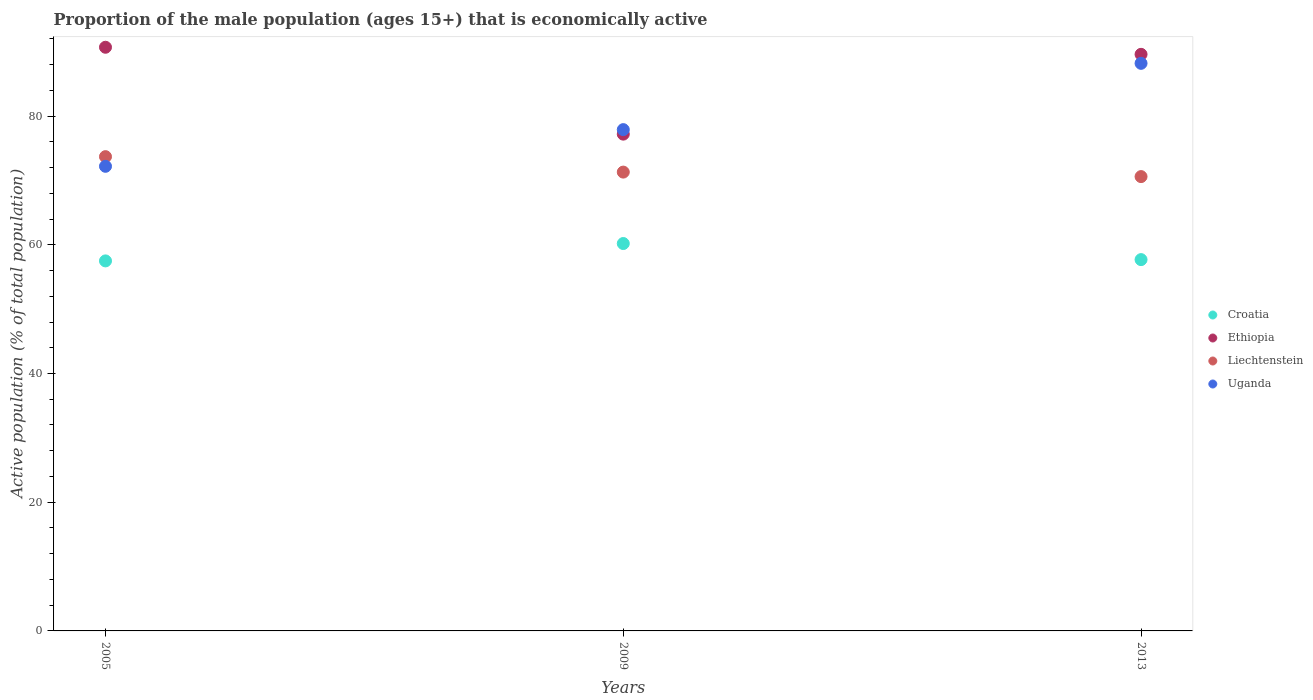How many different coloured dotlines are there?
Keep it short and to the point. 4. What is the proportion of the male population that is economically active in Croatia in 2005?
Provide a short and direct response. 57.5. Across all years, what is the maximum proportion of the male population that is economically active in Uganda?
Your response must be concise. 88.2. Across all years, what is the minimum proportion of the male population that is economically active in Uganda?
Offer a very short reply. 72.2. What is the total proportion of the male population that is economically active in Liechtenstein in the graph?
Keep it short and to the point. 215.6. What is the difference between the proportion of the male population that is economically active in Uganda in 2005 and that in 2009?
Ensure brevity in your answer.  -5.7. What is the difference between the proportion of the male population that is economically active in Liechtenstein in 2013 and the proportion of the male population that is economically active in Uganda in 2005?
Keep it short and to the point. -1.6. What is the average proportion of the male population that is economically active in Liechtenstein per year?
Your answer should be very brief. 71.87. In the year 2009, what is the difference between the proportion of the male population that is economically active in Liechtenstein and proportion of the male population that is economically active in Uganda?
Give a very brief answer. -6.6. What is the ratio of the proportion of the male population that is economically active in Croatia in 2009 to that in 2013?
Make the answer very short. 1.04. Is the proportion of the male population that is economically active in Croatia in 2005 less than that in 2009?
Make the answer very short. Yes. Is the difference between the proportion of the male population that is economically active in Liechtenstein in 2009 and 2013 greater than the difference between the proportion of the male population that is economically active in Uganda in 2009 and 2013?
Provide a short and direct response. Yes. What is the difference between the highest and the second highest proportion of the male population that is economically active in Ethiopia?
Your answer should be compact. 1.1. What is the difference between the highest and the lowest proportion of the male population that is economically active in Ethiopia?
Provide a short and direct response. 13.5. Is the sum of the proportion of the male population that is economically active in Liechtenstein in 2005 and 2013 greater than the maximum proportion of the male population that is economically active in Ethiopia across all years?
Your response must be concise. Yes. Is it the case that in every year, the sum of the proportion of the male population that is economically active in Croatia and proportion of the male population that is economically active in Uganda  is greater than the sum of proportion of the male population that is economically active in Liechtenstein and proportion of the male population that is economically active in Ethiopia?
Give a very brief answer. No. Does the proportion of the male population that is economically active in Ethiopia monotonically increase over the years?
Give a very brief answer. No. Is the proportion of the male population that is economically active in Croatia strictly greater than the proportion of the male population that is economically active in Ethiopia over the years?
Give a very brief answer. No. What is the difference between two consecutive major ticks on the Y-axis?
Offer a very short reply. 20. Are the values on the major ticks of Y-axis written in scientific E-notation?
Your response must be concise. No. Does the graph contain any zero values?
Your response must be concise. No. Does the graph contain grids?
Provide a short and direct response. No. How many legend labels are there?
Offer a very short reply. 4. How are the legend labels stacked?
Your answer should be very brief. Vertical. What is the title of the graph?
Keep it short and to the point. Proportion of the male population (ages 15+) that is economically active. Does "North America" appear as one of the legend labels in the graph?
Offer a very short reply. No. What is the label or title of the Y-axis?
Offer a very short reply. Active population (% of total population). What is the Active population (% of total population) of Croatia in 2005?
Give a very brief answer. 57.5. What is the Active population (% of total population) of Ethiopia in 2005?
Your answer should be compact. 90.7. What is the Active population (% of total population) in Liechtenstein in 2005?
Your answer should be compact. 73.7. What is the Active population (% of total population) in Uganda in 2005?
Provide a short and direct response. 72.2. What is the Active population (% of total population) of Croatia in 2009?
Keep it short and to the point. 60.2. What is the Active population (% of total population) in Ethiopia in 2009?
Make the answer very short. 77.2. What is the Active population (% of total population) of Liechtenstein in 2009?
Make the answer very short. 71.3. What is the Active population (% of total population) of Uganda in 2009?
Ensure brevity in your answer.  77.9. What is the Active population (% of total population) of Croatia in 2013?
Keep it short and to the point. 57.7. What is the Active population (% of total population) of Ethiopia in 2013?
Provide a succinct answer. 89.6. What is the Active population (% of total population) in Liechtenstein in 2013?
Your answer should be very brief. 70.6. What is the Active population (% of total population) in Uganda in 2013?
Offer a very short reply. 88.2. Across all years, what is the maximum Active population (% of total population) in Croatia?
Make the answer very short. 60.2. Across all years, what is the maximum Active population (% of total population) of Ethiopia?
Offer a very short reply. 90.7. Across all years, what is the maximum Active population (% of total population) of Liechtenstein?
Make the answer very short. 73.7. Across all years, what is the maximum Active population (% of total population) of Uganda?
Keep it short and to the point. 88.2. Across all years, what is the minimum Active population (% of total population) in Croatia?
Make the answer very short. 57.5. Across all years, what is the minimum Active population (% of total population) of Ethiopia?
Give a very brief answer. 77.2. Across all years, what is the minimum Active population (% of total population) of Liechtenstein?
Provide a short and direct response. 70.6. Across all years, what is the minimum Active population (% of total population) of Uganda?
Keep it short and to the point. 72.2. What is the total Active population (% of total population) of Croatia in the graph?
Make the answer very short. 175.4. What is the total Active population (% of total population) in Ethiopia in the graph?
Your answer should be very brief. 257.5. What is the total Active population (% of total population) in Liechtenstein in the graph?
Offer a very short reply. 215.6. What is the total Active population (% of total population) of Uganda in the graph?
Your response must be concise. 238.3. What is the difference between the Active population (% of total population) in Ethiopia in 2005 and that in 2009?
Your response must be concise. 13.5. What is the difference between the Active population (% of total population) in Uganda in 2005 and that in 2009?
Keep it short and to the point. -5.7. What is the difference between the Active population (% of total population) of Croatia in 2005 and that in 2013?
Keep it short and to the point. -0.2. What is the difference between the Active population (% of total population) of Croatia in 2009 and that in 2013?
Offer a terse response. 2.5. What is the difference between the Active population (% of total population) of Croatia in 2005 and the Active population (% of total population) of Ethiopia in 2009?
Keep it short and to the point. -19.7. What is the difference between the Active population (% of total population) in Croatia in 2005 and the Active population (% of total population) in Liechtenstein in 2009?
Your response must be concise. -13.8. What is the difference between the Active population (% of total population) in Croatia in 2005 and the Active population (% of total population) in Uganda in 2009?
Ensure brevity in your answer.  -20.4. What is the difference between the Active population (% of total population) of Ethiopia in 2005 and the Active population (% of total population) of Uganda in 2009?
Make the answer very short. 12.8. What is the difference between the Active population (% of total population) in Liechtenstein in 2005 and the Active population (% of total population) in Uganda in 2009?
Provide a succinct answer. -4.2. What is the difference between the Active population (% of total population) in Croatia in 2005 and the Active population (% of total population) in Ethiopia in 2013?
Keep it short and to the point. -32.1. What is the difference between the Active population (% of total population) in Croatia in 2005 and the Active population (% of total population) in Uganda in 2013?
Provide a short and direct response. -30.7. What is the difference between the Active population (% of total population) in Ethiopia in 2005 and the Active population (% of total population) in Liechtenstein in 2013?
Provide a succinct answer. 20.1. What is the difference between the Active population (% of total population) in Liechtenstein in 2005 and the Active population (% of total population) in Uganda in 2013?
Offer a very short reply. -14.5. What is the difference between the Active population (% of total population) in Croatia in 2009 and the Active population (% of total population) in Ethiopia in 2013?
Your answer should be compact. -29.4. What is the difference between the Active population (% of total population) of Croatia in 2009 and the Active population (% of total population) of Uganda in 2013?
Offer a very short reply. -28. What is the difference between the Active population (% of total population) in Ethiopia in 2009 and the Active population (% of total population) in Uganda in 2013?
Keep it short and to the point. -11. What is the difference between the Active population (% of total population) of Liechtenstein in 2009 and the Active population (% of total population) of Uganda in 2013?
Make the answer very short. -16.9. What is the average Active population (% of total population) of Croatia per year?
Your answer should be very brief. 58.47. What is the average Active population (% of total population) in Ethiopia per year?
Give a very brief answer. 85.83. What is the average Active population (% of total population) of Liechtenstein per year?
Your response must be concise. 71.87. What is the average Active population (% of total population) in Uganda per year?
Give a very brief answer. 79.43. In the year 2005, what is the difference between the Active population (% of total population) of Croatia and Active population (% of total population) of Ethiopia?
Ensure brevity in your answer.  -33.2. In the year 2005, what is the difference between the Active population (% of total population) of Croatia and Active population (% of total population) of Liechtenstein?
Offer a terse response. -16.2. In the year 2005, what is the difference between the Active population (% of total population) of Croatia and Active population (% of total population) of Uganda?
Keep it short and to the point. -14.7. In the year 2005, what is the difference between the Active population (% of total population) in Ethiopia and Active population (% of total population) in Liechtenstein?
Your answer should be very brief. 17. In the year 2005, what is the difference between the Active population (% of total population) in Ethiopia and Active population (% of total population) in Uganda?
Keep it short and to the point. 18.5. In the year 2009, what is the difference between the Active population (% of total population) of Croatia and Active population (% of total population) of Ethiopia?
Offer a very short reply. -17. In the year 2009, what is the difference between the Active population (% of total population) of Croatia and Active population (% of total population) of Uganda?
Ensure brevity in your answer.  -17.7. In the year 2013, what is the difference between the Active population (% of total population) of Croatia and Active population (% of total population) of Ethiopia?
Your response must be concise. -31.9. In the year 2013, what is the difference between the Active population (% of total population) in Croatia and Active population (% of total population) in Uganda?
Your answer should be very brief. -30.5. In the year 2013, what is the difference between the Active population (% of total population) of Ethiopia and Active population (% of total population) of Liechtenstein?
Offer a terse response. 19. In the year 2013, what is the difference between the Active population (% of total population) in Ethiopia and Active population (% of total population) in Uganda?
Give a very brief answer. 1.4. In the year 2013, what is the difference between the Active population (% of total population) of Liechtenstein and Active population (% of total population) of Uganda?
Provide a succinct answer. -17.6. What is the ratio of the Active population (% of total population) in Croatia in 2005 to that in 2009?
Offer a terse response. 0.96. What is the ratio of the Active population (% of total population) of Ethiopia in 2005 to that in 2009?
Your answer should be compact. 1.17. What is the ratio of the Active population (% of total population) of Liechtenstein in 2005 to that in 2009?
Make the answer very short. 1.03. What is the ratio of the Active population (% of total population) of Uganda in 2005 to that in 2009?
Ensure brevity in your answer.  0.93. What is the ratio of the Active population (% of total population) in Croatia in 2005 to that in 2013?
Offer a terse response. 1. What is the ratio of the Active population (% of total population) of Ethiopia in 2005 to that in 2013?
Your response must be concise. 1.01. What is the ratio of the Active population (% of total population) in Liechtenstein in 2005 to that in 2013?
Keep it short and to the point. 1.04. What is the ratio of the Active population (% of total population) in Uganda in 2005 to that in 2013?
Give a very brief answer. 0.82. What is the ratio of the Active population (% of total population) in Croatia in 2009 to that in 2013?
Your answer should be very brief. 1.04. What is the ratio of the Active population (% of total population) in Ethiopia in 2009 to that in 2013?
Offer a terse response. 0.86. What is the ratio of the Active population (% of total population) in Liechtenstein in 2009 to that in 2013?
Provide a succinct answer. 1.01. What is the ratio of the Active population (% of total population) of Uganda in 2009 to that in 2013?
Your answer should be compact. 0.88. What is the difference between the highest and the second highest Active population (% of total population) of Uganda?
Your answer should be compact. 10.3. What is the difference between the highest and the lowest Active population (% of total population) in Croatia?
Give a very brief answer. 2.7. What is the difference between the highest and the lowest Active population (% of total population) of Ethiopia?
Offer a very short reply. 13.5. What is the difference between the highest and the lowest Active population (% of total population) of Uganda?
Ensure brevity in your answer.  16. 